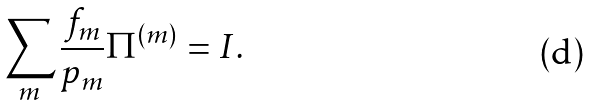<formula> <loc_0><loc_0><loc_500><loc_500>\sum _ { m } \frac { f _ { m } } { p _ { m } } \Pi ^ { ( m ) } = I .</formula> 